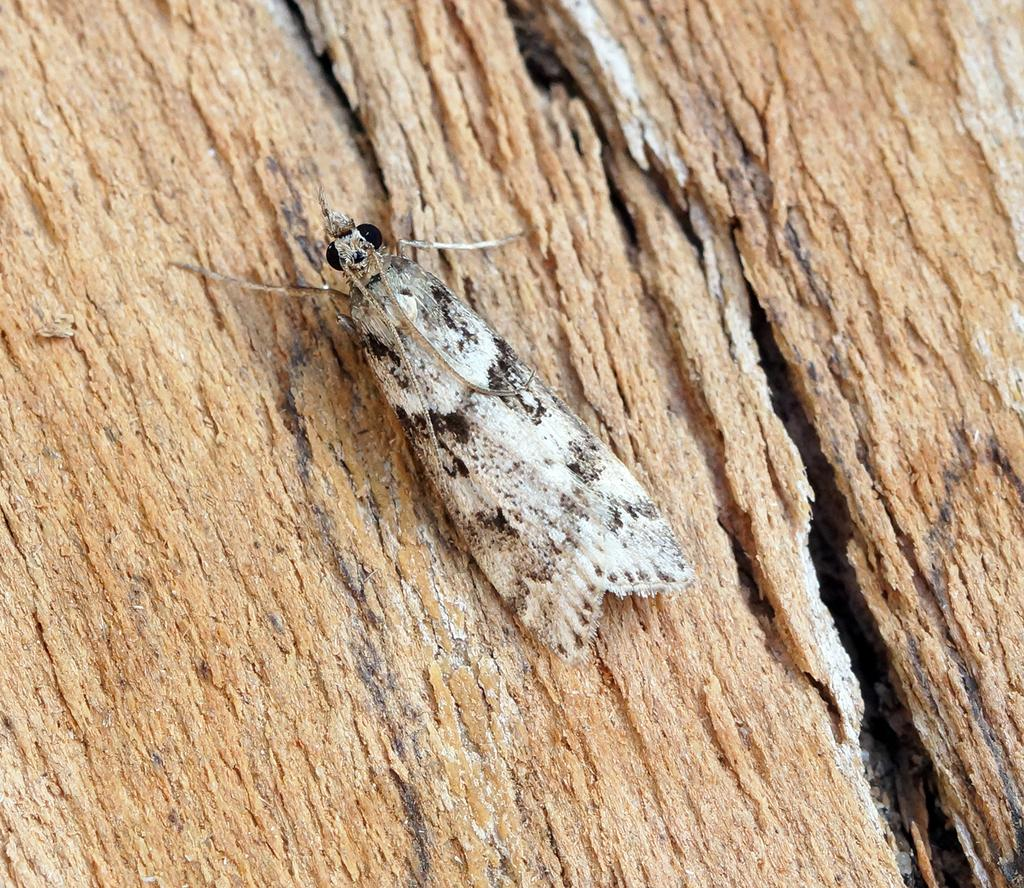What is the main subject of the image? The main subject of the image is a butterfly. What is the butterfly resting on? The butterfly is on wood. What type of power source is visible in the image? There is no power source visible in the image; it features a butterfly on wood. What type of nerve can be seen in the image? There are no nerves present in the image; it features a butterfly on wood. 